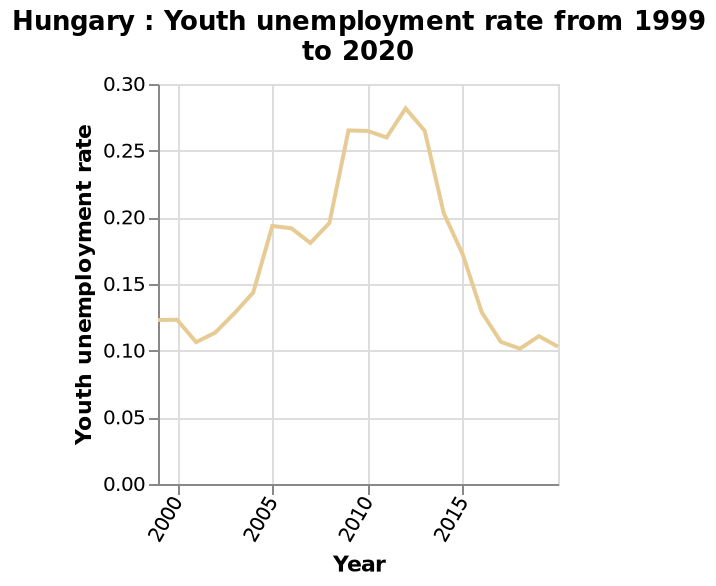<image>
What is the title of the line plot? The title of the line plot is "Hungary: Youth unemployment rate from 1999 to 2020". Has youth unemployment been decreasing in Hungary since its peak in 2012?  Yes, youth unemployment has been falling in Hungary since its peak in 2012. Was there a small increase in youth unemployment in Hungary in 2019?  Yes, there was a small rise in youth unemployment in Hungary in 2019. 